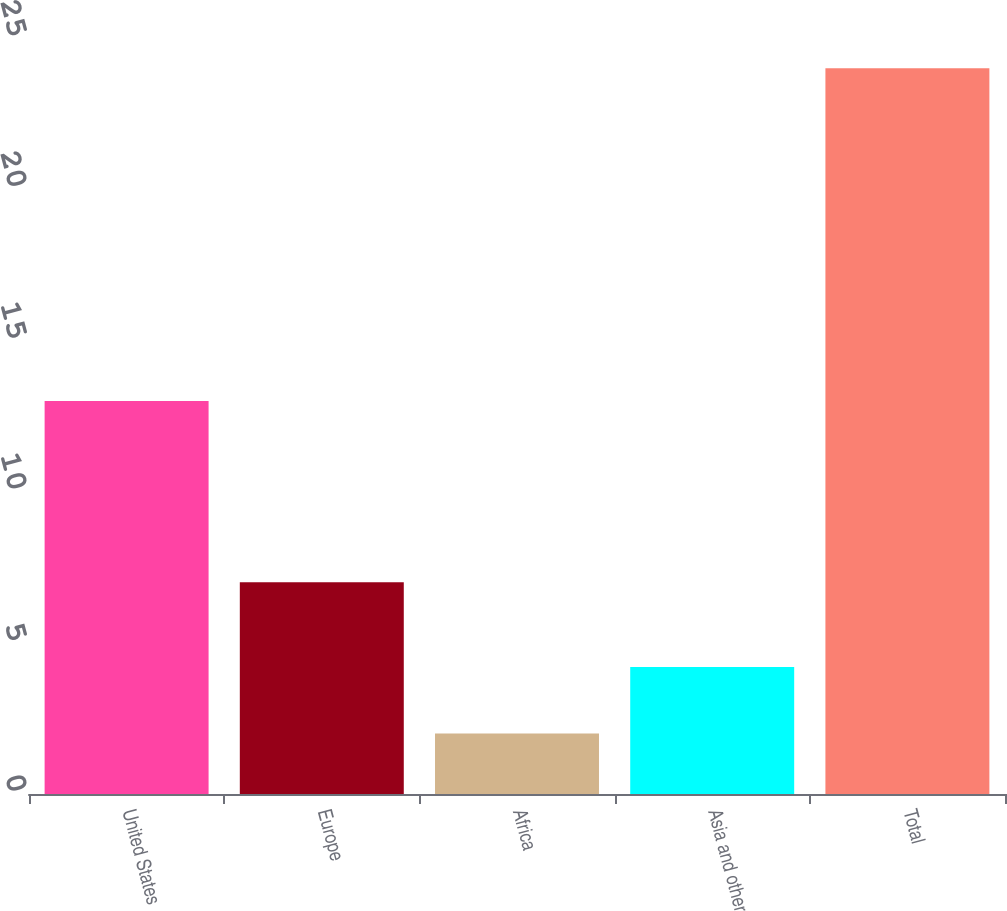Convert chart to OTSL. <chart><loc_0><loc_0><loc_500><loc_500><bar_chart><fcel>United States<fcel>Europe<fcel>Africa<fcel>Asia and other<fcel>Total<nl><fcel>13<fcel>7<fcel>2<fcel>4.2<fcel>24<nl></chart> 